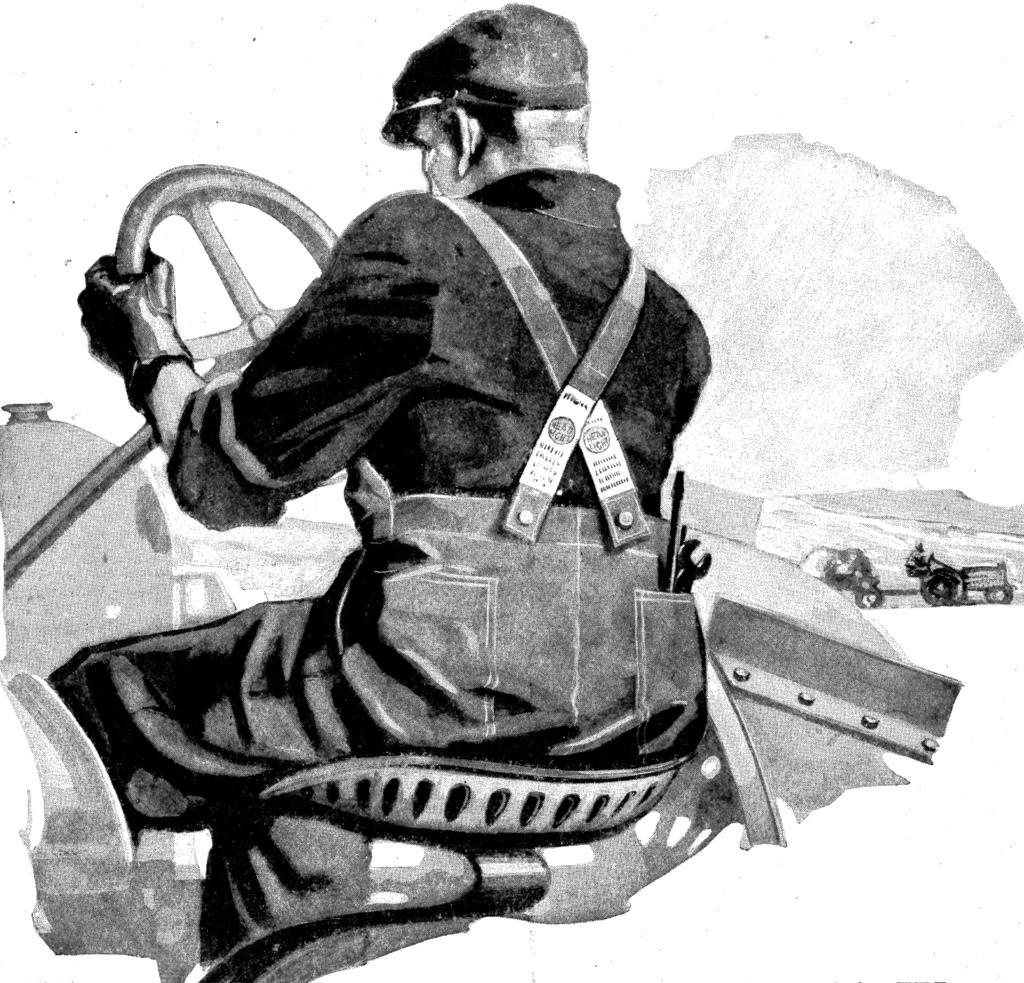Please provide a concise description of this image. In this image, we can see a painting which is in black and white. In this image, in the middle, we can see a man sitting in the vehicle and holding steering in his hand. On the right side, we can see two vehicles riding by two persons, mountains. At the top, we can see a sky, at the bottom, we can also see a white color. 